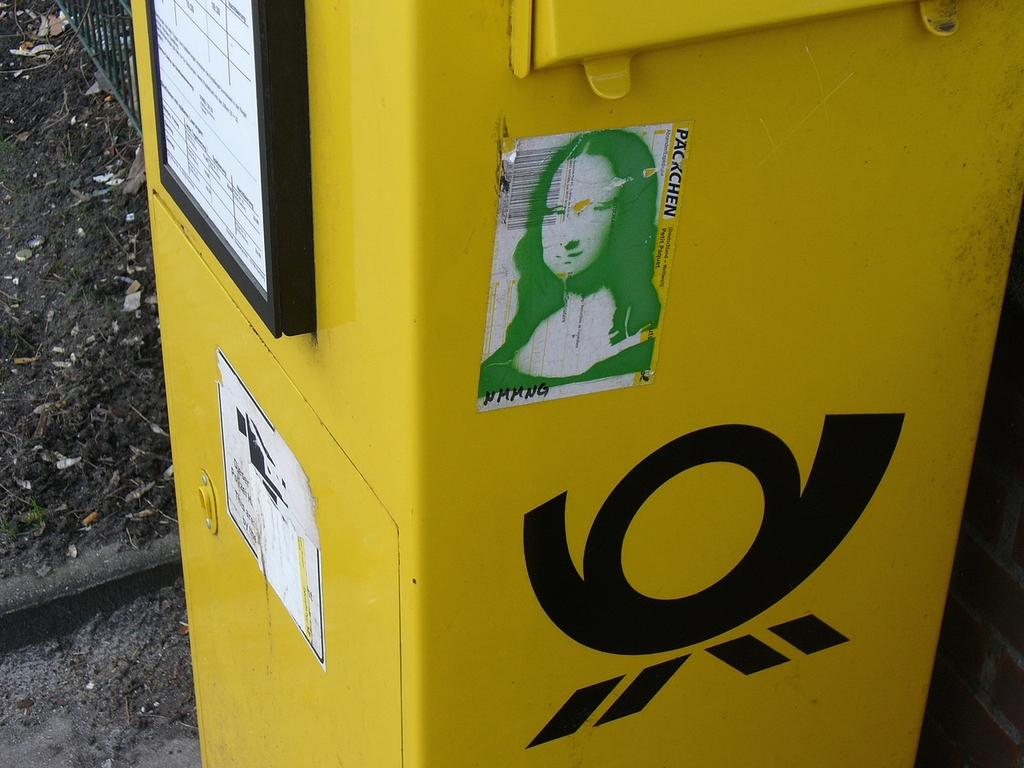<image>
Present a compact description of the photo's key features. A yellow receptacle in the outdoors with a Packchen sticker on it 